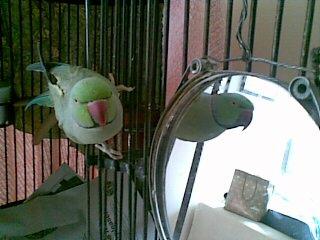What kind of bird is this?
Give a very brief answer. Parrot. Is there any mirror near to the bird?
Write a very short answer. Yes. What is the bird looking at?
Concise answer only. Camera. What animal is next to the plant?
Keep it brief. Bird. How many cats are in the image?
Quick response, please. 0. 